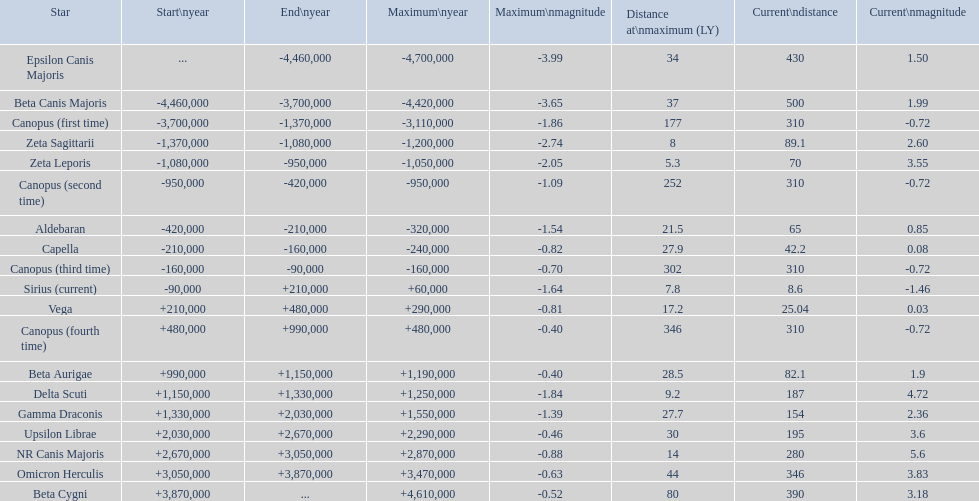What star has a a maximum magnitude of -0.63. Omicron Herculis. What star has a current distance of 390? Beta Cygni. 